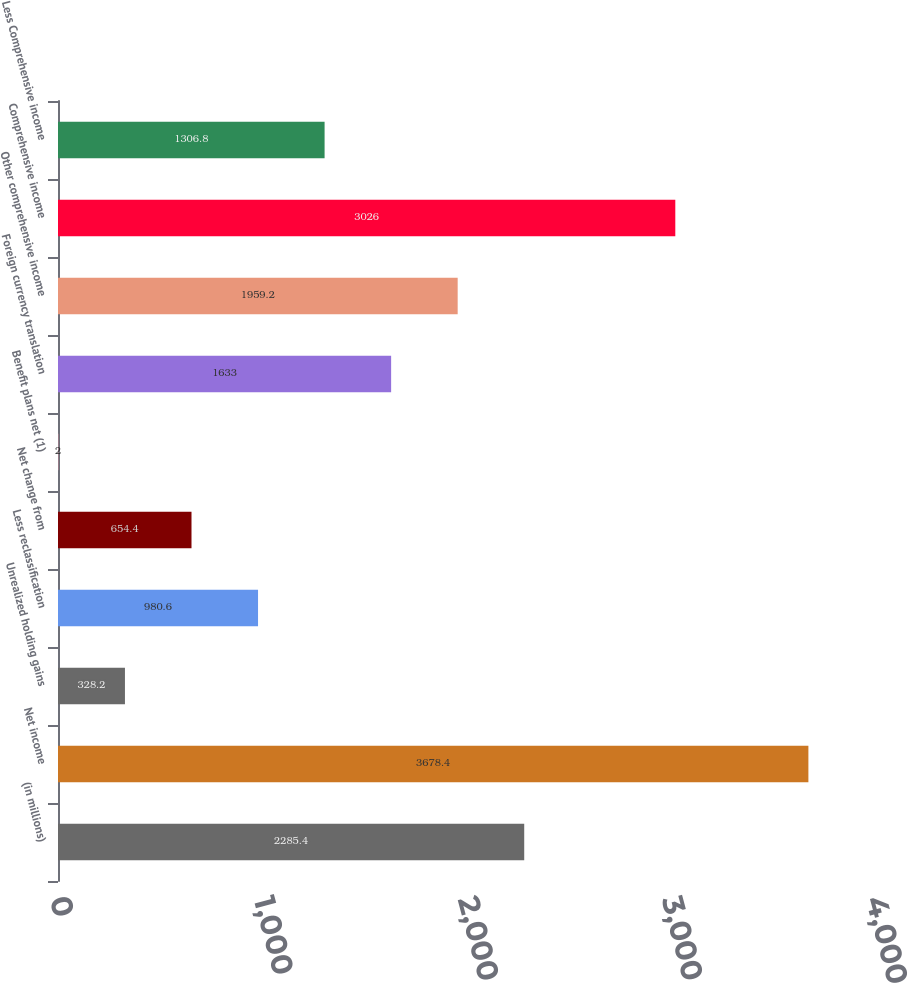Convert chart. <chart><loc_0><loc_0><loc_500><loc_500><bar_chart><fcel>(in millions)<fcel>Net income<fcel>Unrealized holding gains<fcel>Less reclassification<fcel>Net change from<fcel>Benefit plans net (1)<fcel>Foreign currency translation<fcel>Other comprehensive income<fcel>Comprehensive income<fcel>Less Comprehensive income<nl><fcel>2285.4<fcel>3678.4<fcel>328.2<fcel>980.6<fcel>654.4<fcel>2<fcel>1633<fcel>1959.2<fcel>3026<fcel>1306.8<nl></chart> 